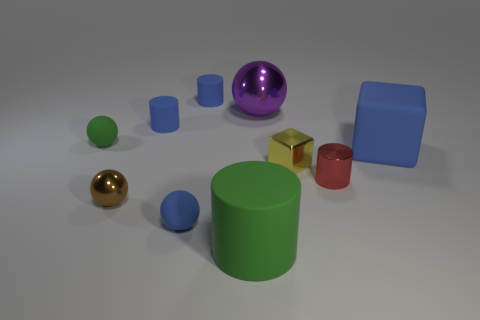What size is the green object in front of the tiny green sphere?
Give a very brief answer. Large. The purple metallic object is what shape?
Provide a short and direct response. Sphere. Is the size of the sphere that is to the left of the brown object the same as the shiny sphere that is on the right side of the blue matte ball?
Make the answer very short. No. How big is the blue matte thing right of the large thing behind the matte sphere on the left side of the brown metal sphere?
Provide a succinct answer. Large. The metallic object left of the small matte cylinder behind the blue matte thing that is on the left side of the blue ball is what shape?
Provide a short and direct response. Sphere. What shape is the large purple object that is to the left of the small metallic cylinder?
Make the answer very short. Sphere. Are the green sphere and the blue object that is in front of the brown ball made of the same material?
Keep it short and to the point. Yes. How many other things are there of the same shape as the tiny yellow object?
Keep it short and to the point. 1. Do the big cube and the matte ball in front of the yellow metal thing have the same color?
Provide a succinct answer. Yes. The tiny blue thing that is behind the metal ball behind the small red object is what shape?
Provide a succinct answer. Cylinder. 